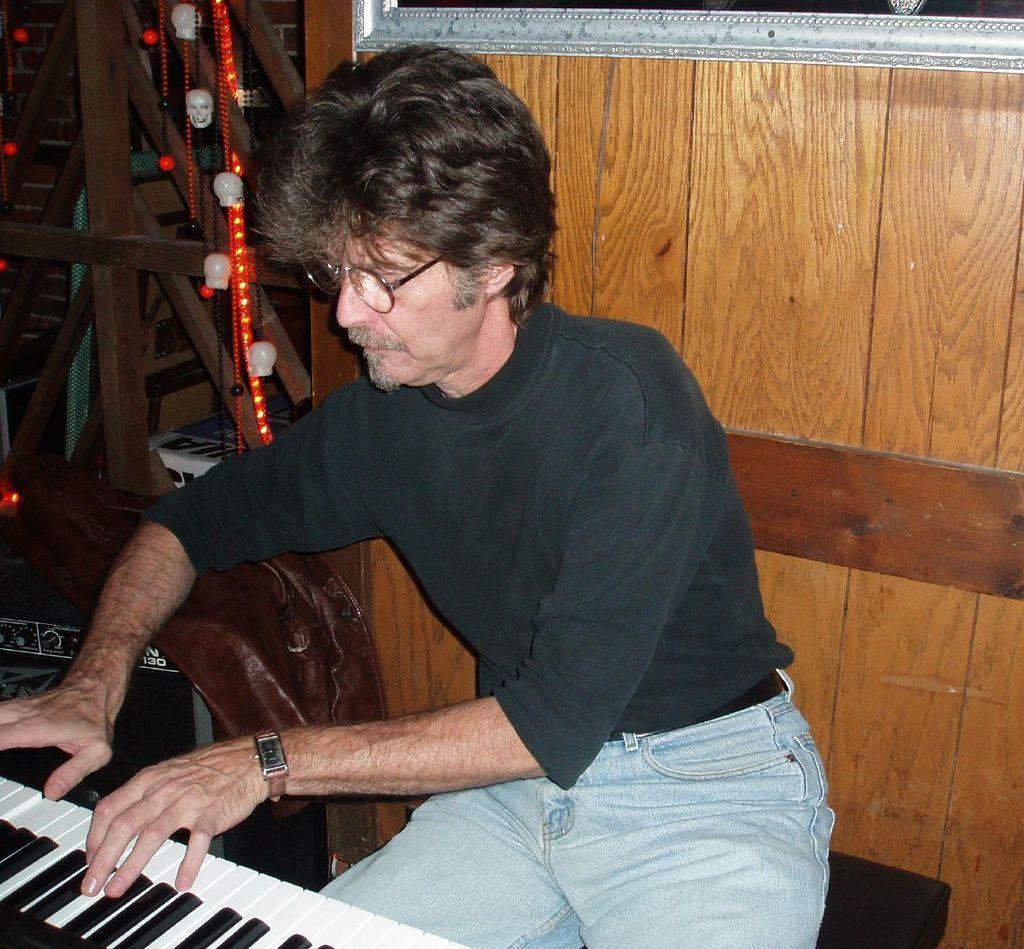Please provide a concise description of this image. In this image a man is sitting on the chair and he is playing the music on the keyboard. He is wearing spectacles. In the background there is a wall which is made of wood and there are few lights with ribbons. 